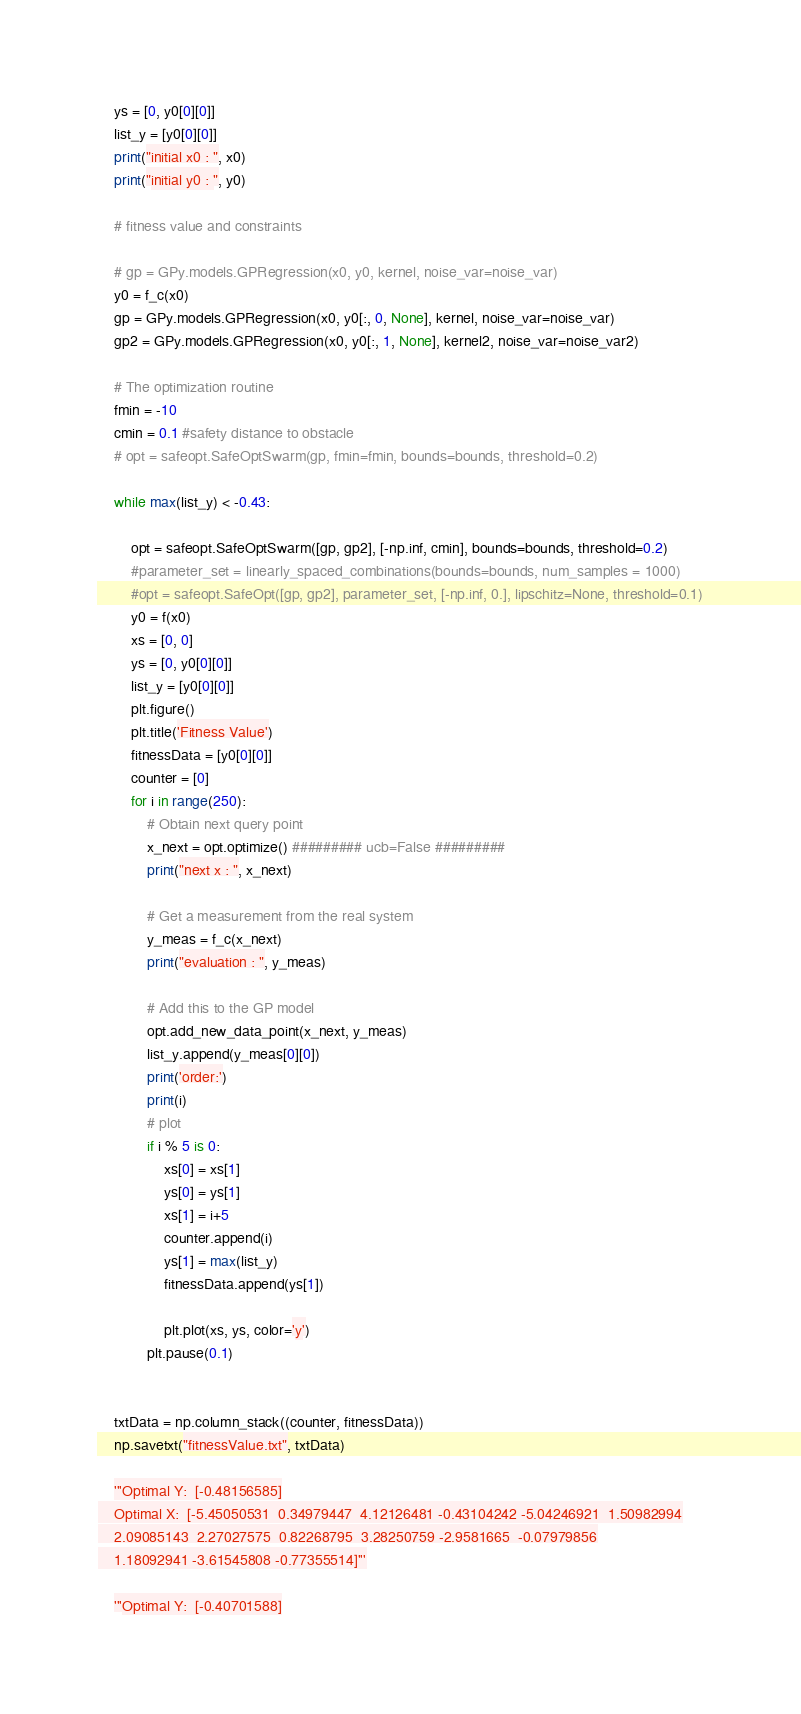<code> <loc_0><loc_0><loc_500><loc_500><_Python_>    ys = [0, y0[0][0]]
    list_y = [y0[0][0]]
    print("initial x0 : ", x0)
    print("initial y0 : ", y0)

    # fitness value and constraints

    # gp = GPy.models.GPRegression(x0, y0, kernel, noise_var=noise_var)
    y0 = f_c(x0)
    gp = GPy.models.GPRegression(x0, y0[:, 0, None], kernel, noise_var=noise_var)
    gp2 = GPy.models.GPRegression(x0, y0[:, 1, None], kernel2, noise_var=noise_var2)

    # The optimization routine
    fmin = -10
    cmin = 0.1 #safety distance to obstacle
    # opt = safeopt.SafeOptSwarm(gp, fmin=fmin, bounds=bounds, threshold=0.2)

    while max(list_y) < -0.43:

        opt = safeopt.SafeOptSwarm([gp, gp2], [-np.inf, cmin], bounds=bounds, threshold=0.2)
        #parameter_set = linearly_spaced_combinations(bounds=bounds, num_samples = 1000)
        #opt = safeopt.SafeOpt([gp, gp2], parameter_set, [-np.inf, 0.], lipschitz=None, threshold=0.1)
        y0 = f(x0)
        xs = [0, 0]
        ys = [0, y0[0][0]]
        list_y = [y0[0][0]]
        plt.figure()
        plt.title('Fitness Value')
        fitnessData = [y0[0][0]]
        counter = [0]
        for i in range(250):
            # Obtain next query point
            x_next = opt.optimize() ######### ucb=False #########
            print("next x : ", x_next)

            # Get a measurement from the real system
            y_meas = f_c(x_next)
            print("evaluation : ", y_meas)

            # Add this to the GP model
            opt.add_new_data_point(x_next, y_meas)
            list_y.append(y_meas[0][0])
            print('order:')
            print(i)
            # plot
            if i % 5 is 0:
                xs[0] = xs[1]
                ys[0] = ys[1]
                xs[1] = i+5
                counter.append(i)
                ys[1] = max(list_y)
                fitnessData.append(ys[1])

                plt.plot(xs, ys, color='y')
            plt.pause(0.1)


    txtData = np.column_stack((counter, fitnessData))
    np.savetxt("fitnessValue.txt", txtData)

    '''Optimal Y:  [-0.48156585]
    Optimal X:  [-5.45050531  0.34979447  4.12126481 -0.43104242 -5.04246921  1.50982994
    2.09085143  2.27027575  0.82268795  3.28250759 -2.9581665  -0.07979856
    1.18092941 -3.61545808 -0.77355514]'''

    '''Optimal Y:  [-0.40701588]</code> 